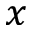Convert formula to latex. <formula><loc_0><loc_0><loc_500><loc_500>x</formula> 